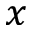Convert formula to latex. <formula><loc_0><loc_0><loc_500><loc_500>x</formula> 